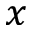Convert formula to latex. <formula><loc_0><loc_0><loc_500><loc_500>x</formula> 